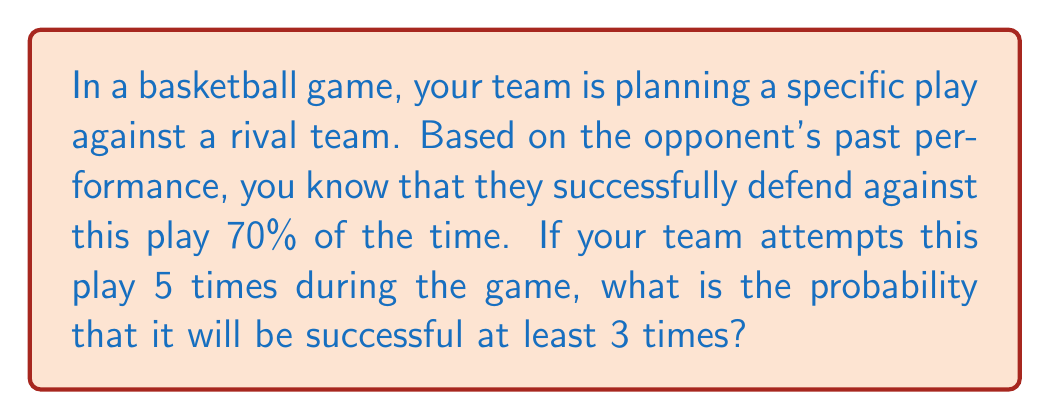Can you answer this question? Let's approach this step-by-step:

1) First, we need to identify the probability of success for a single attempt:
   If the opponent defends successfully 70% of the time, then the probability of your team's success is:
   $p = 1 - 0.70 = 0.30$ or 30%

2) We're looking for the probability of at least 3 successes out of 5 attempts. This can be calculated as:
   $P(\text{at least 3 successes}) = P(3 \text{ successes}) + P(4 \text{ successes}) + P(5 \text{ successes})$

3) We can use the binomial probability formula for each of these:
   $P(X = k) = \binom{n}{k} p^k (1-p)^{n-k}$
   where $n = 5$ (total attempts), $k$ is the number of successes, $p = 0.30$

4) Let's calculate each probability:

   For 3 successes: $P(3) = \binom{5}{3} (0.30)^3 (0.70)^2 = 10 \times 0.027 \times 0.49 = 0.1323$

   For 4 successes: $P(4) = \binom{5}{4} (0.30)^4 (0.70)^1 = 5 \times 0.0081 \times 0.70 = 0.02835$

   For 5 successes: $P(5) = \binom{5}{5} (0.30)^5 (0.70)^0 = 1 \times 0.00243 \times 1 = 0.00243$

5) Now, we sum these probabilities:
   $P(\text{at least 3 successes}) = 0.1323 + 0.02835 + 0.00243 = 0.16308$

Therefore, the probability of the play being successful at least 3 times out of 5 attempts is approximately 0.16308 or 16.31%.
Answer: $0.16308$ or $16.31\%$ 